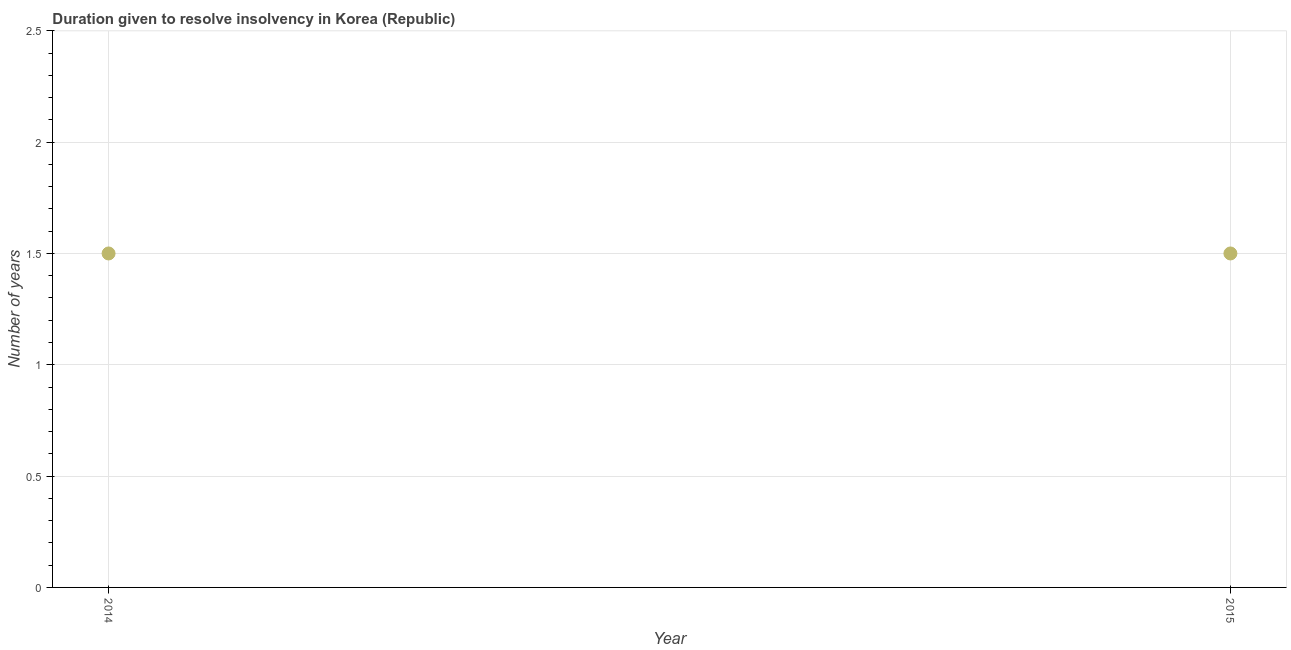In which year was the number of years to resolve insolvency maximum?
Provide a succinct answer. 2014. In which year was the number of years to resolve insolvency minimum?
Your response must be concise. 2014. What is the sum of the number of years to resolve insolvency?
Give a very brief answer. 3. What is the difference between the number of years to resolve insolvency in 2014 and 2015?
Offer a terse response. 0. Is the number of years to resolve insolvency in 2014 less than that in 2015?
Your answer should be compact. No. In how many years, is the number of years to resolve insolvency greater than the average number of years to resolve insolvency taken over all years?
Your answer should be compact. 0. How many dotlines are there?
Your answer should be compact. 1. How many years are there in the graph?
Your answer should be very brief. 2. Are the values on the major ticks of Y-axis written in scientific E-notation?
Give a very brief answer. No. Does the graph contain grids?
Keep it short and to the point. Yes. What is the title of the graph?
Provide a short and direct response. Duration given to resolve insolvency in Korea (Republic). What is the label or title of the X-axis?
Your response must be concise. Year. What is the label or title of the Y-axis?
Offer a terse response. Number of years. What is the Number of years in 2015?
Keep it short and to the point. 1.5. 